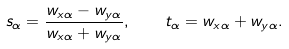<formula> <loc_0><loc_0><loc_500><loc_500>s _ { \alpha } = \frac { w _ { x \alpha } - w _ { y \alpha } } { w _ { x \alpha } + w _ { y \alpha } } , \quad t _ { \alpha } = w _ { x \alpha } + w _ { y \alpha } .</formula> 